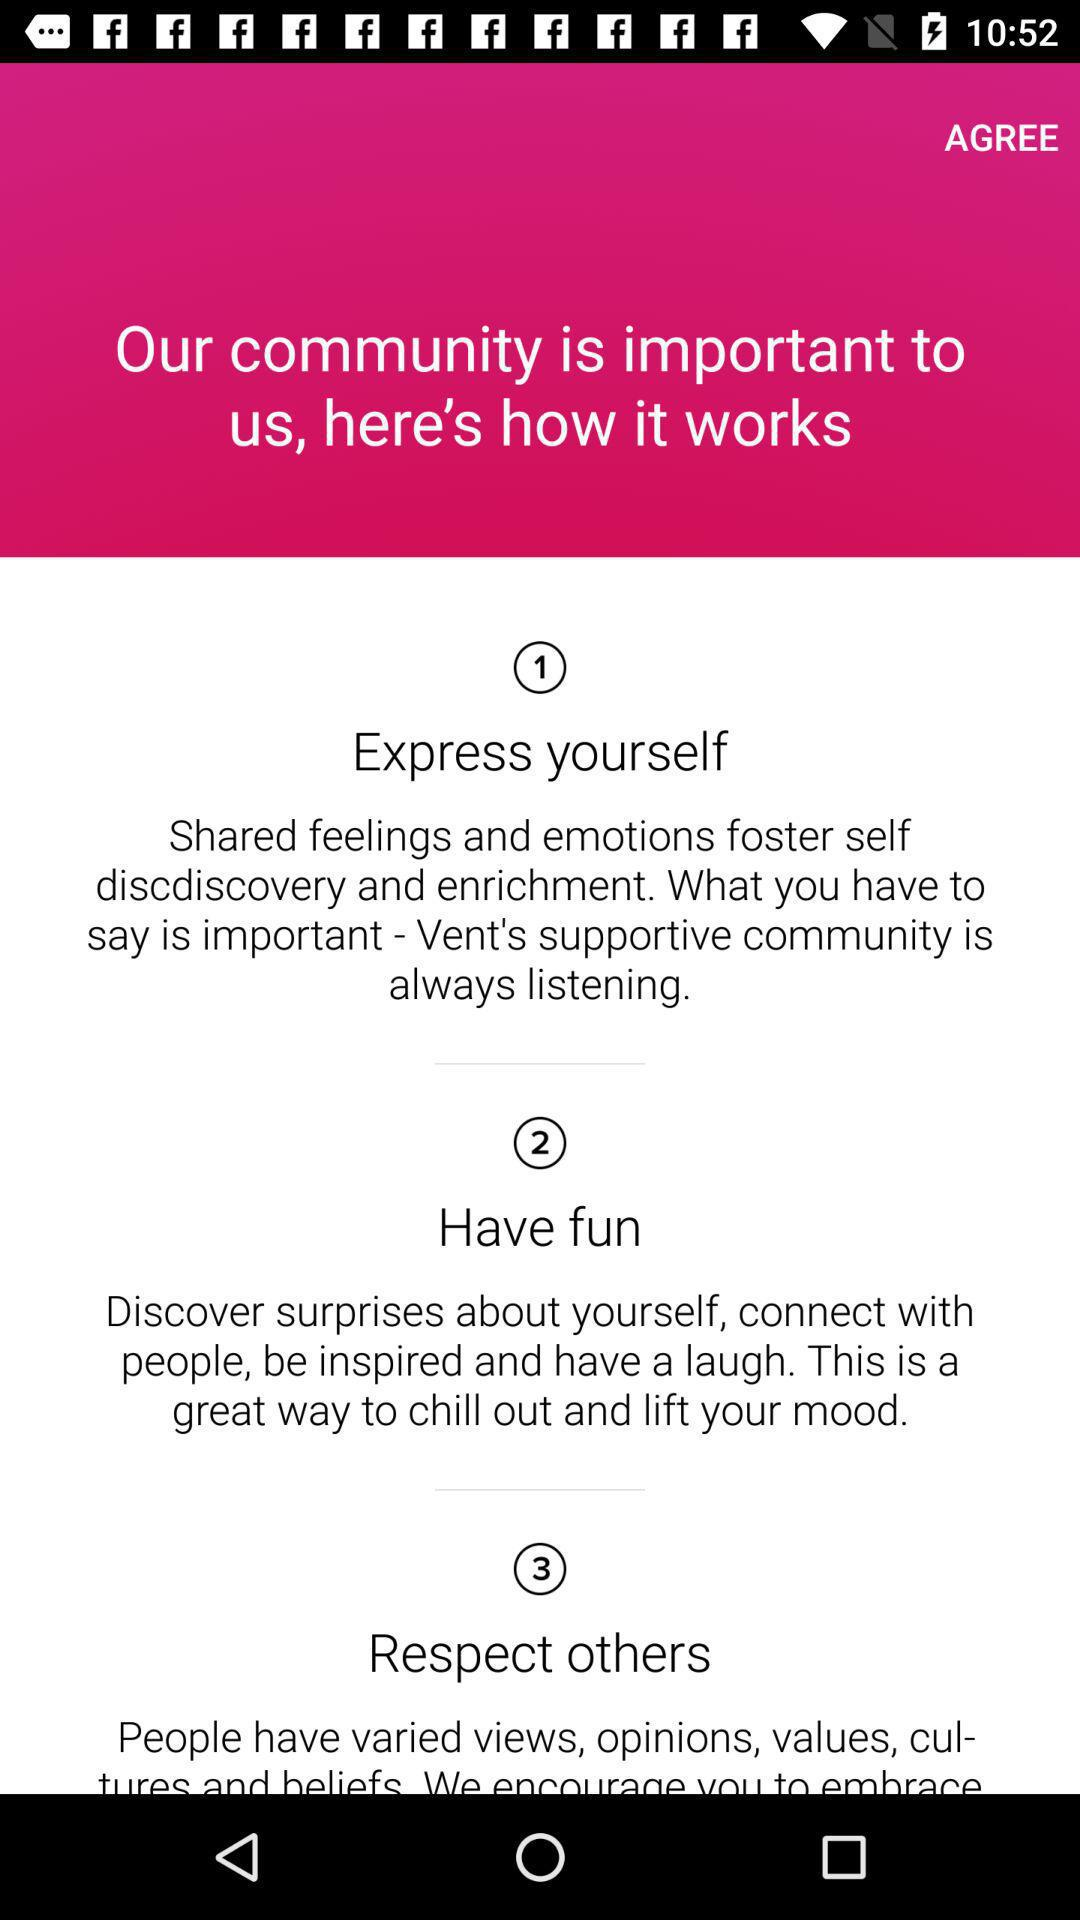What is the topic of point 2? The topic is "Have fun". 